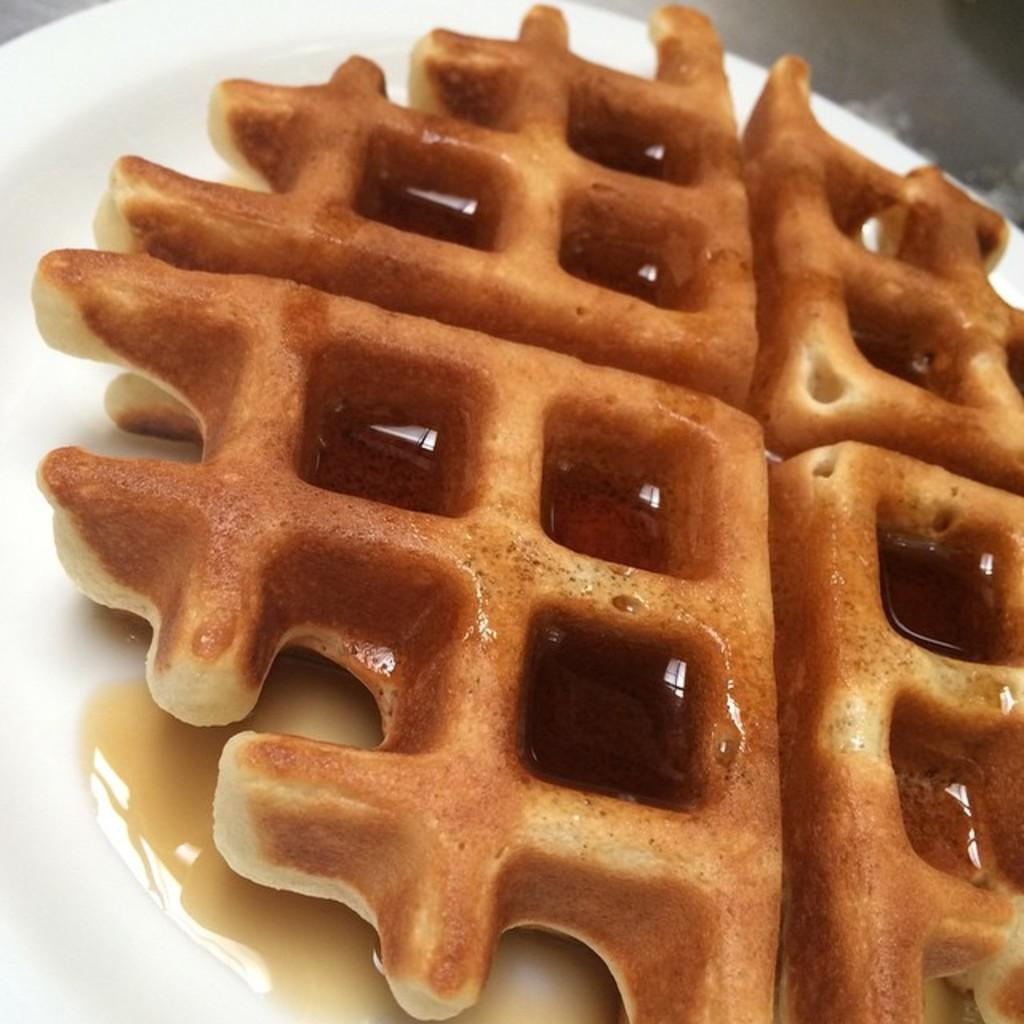What type of dessert is featured in the image? There is a waffle dessert in the image. How is the waffle dessert presented? The waffle dessert is on a plate. What historical event is depicted in the image? There is no historical event depicted in the image; it features a waffle dessert on a plate. 